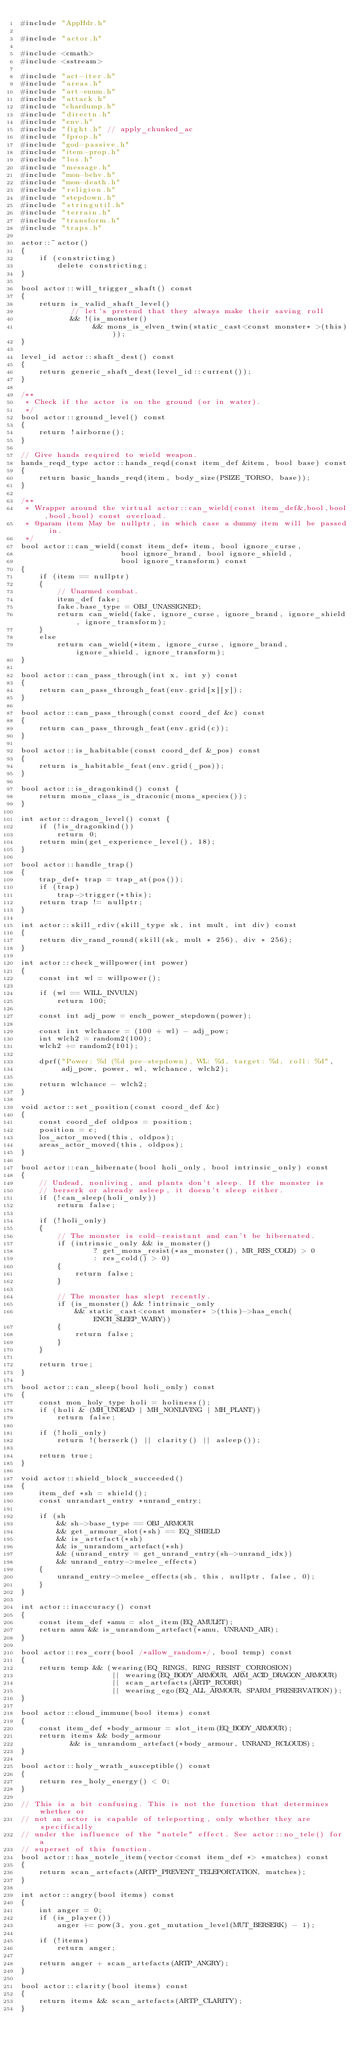<code> <loc_0><loc_0><loc_500><loc_500><_C++_>#include "AppHdr.h"

#include "actor.h"

#include <cmath>
#include <sstream>

#include "act-iter.h"
#include "areas.h"
#include "art-enum.h"
#include "attack.h"
#include "chardump.h"
#include "directn.h"
#include "env.h"
#include "fight.h" // apply_chunked_ac
#include "fprop.h"
#include "god-passive.h"
#include "item-prop.h"
#include "los.h"
#include "message.h"
#include "mon-behv.h"
#include "mon-death.h"
#include "religion.h"
#include "stepdown.h"
#include "stringutil.h"
#include "terrain.h"
#include "transform.h"
#include "traps.h"

actor::~actor()
{
    if (constricting)
        delete constricting;
}

bool actor::will_trigger_shaft() const
{
    return is_valid_shaft_level()
           // let's pretend that they always make their saving roll
           && !(is_monster()
                && mons_is_elven_twin(static_cast<const monster* >(this)));
}

level_id actor::shaft_dest() const
{
    return generic_shaft_dest(level_id::current());
}

/**
 * Check if the actor is on the ground (or in water).
 */
bool actor::ground_level() const
{
    return !airborne();
}

// Give hands required to wield weapon.
hands_reqd_type actor::hands_reqd(const item_def &item, bool base) const
{
    return basic_hands_reqd(item, body_size(PSIZE_TORSO, base));
}

/**
 * Wrapper around the virtual actor::can_wield(const item_def&,bool,bool,bool,bool) const overload.
 * @param item May be nullptr, in which case a dummy item will be passed in.
 */
bool actor::can_wield(const item_def* item, bool ignore_curse,
                      bool ignore_brand, bool ignore_shield,
                      bool ignore_transform) const
{
    if (item == nullptr)
    {
        // Unarmed combat.
        item_def fake;
        fake.base_type = OBJ_UNASSIGNED;
        return can_wield(fake, ignore_curse, ignore_brand, ignore_shield, ignore_transform);
    }
    else
        return can_wield(*item, ignore_curse, ignore_brand, ignore_shield, ignore_transform);
}

bool actor::can_pass_through(int x, int y) const
{
    return can_pass_through_feat(env.grid[x][y]);
}

bool actor::can_pass_through(const coord_def &c) const
{
    return can_pass_through_feat(env.grid(c));
}

bool actor::is_habitable(const coord_def &_pos) const
{
    return is_habitable_feat(env.grid(_pos));
}

bool actor::is_dragonkind() const {
    return mons_class_is_draconic(mons_species());
}

int actor::dragon_level() const {
    if (!is_dragonkind())
        return 0;
    return min(get_experience_level(), 18);
}

bool actor::handle_trap()
{
    trap_def* trap = trap_at(pos());
    if (trap)
        trap->trigger(*this);
    return trap != nullptr;
}

int actor::skill_rdiv(skill_type sk, int mult, int div) const
{
    return div_rand_round(skill(sk, mult * 256), div * 256);
}

int actor::check_willpower(int power)
{
    const int wl = willpower();

    if (wl == WILL_INVULN)
        return 100;

    const int adj_pow = ench_power_stepdown(power);

    const int wlchance = (100 + wl) - adj_pow;
    int wlch2 = random2(100);
    wlch2 += random2(101);

    dprf("Power: %d (%d pre-stepdown), WL: %d, target: %d, roll: %d",
         adj_pow, power, wl, wlchance, wlch2);

    return wlchance - wlch2;
}

void actor::set_position(const coord_def &c)
{
    const coord_def oldpos = position;
    position = c;
    los_actor_moved(this, oldpos);
    areas_actor_moved(this, oldpos);
}

bool actor::can_hibernate(bool holi_only, bool intrinsic_only) const
{
    // Undead, nonliving, and plants don't sleep. If the monster is
    // berserk or already asleep, it doesn't sleep either.
    if (!can_sleep(holi_only))
        return false;

    if (!holi_only)
    {
        // The monster is cold-resistant and can't be hibernated.
        if (intrinsic_only && is_monster()
                ? get_mons_resist(*as_monster(), MR_RES_COLD) > 0
                : res_cold() > 0)
        {
            return false;
        }

        // The monster has slept recently.
        if (is_monster() && !intrinsic_only
            && static_cast<const monster* >(this)->has_ench(ENCH_SLEEP_WARY))
        {
            return false;
        }
    }

    return true;
}

bool actor::can_sleep(bool holi_only) const
{
    const mon_holy_type holi = holiness();
    if (holi & (MH_UNDEAD | MH_NONLIVING | MH_PLANT))
        return false;

    if (!holi_only)
        return !(berserk() || clarity() || asleep());

    return true;
}

void actor::shield_block_succeeded()
{
    item_def *sh = shield();
    const unrandart_entry *unrand_entry;

    if (sh
        && sh->base_type == OBJ_ARMOUR
        && get_armour_slot(*sh) == EQ_SHIELD
        && is_artefact(*sh)
        && is_unrandom_artefact(*sh)
        && (unrand_entry = get_unrand_entry(sh->unrand_idx))
        && unrand_entry->melee_effects)
    {
        unrand_entry->melee_effects(sh, this, nullptr, false, 0);
    }
}

int actor::inaccuracy() const
{
    const item_def *amu = slot_item(EQ_AMULET);
    return amu && is_unrandom_artefact(*amu, UNRAND_AIR);
}

bool actor::res_corr(bool /*allow_random*/, bool temp) const
{
    return temp && (wearing(EQ_RINGS, RING_RESIST_CORROSION)
                    || wearing(EQ_BODY_ARMOUR, ARM_ACID_DRAGON_ARMOUR)
                    || scan_artefacts(ARTP_RCORR)
                    || wearing_ego(EQ_ALL_ARMOUR, SPARM_PRESERVATION));
}

bool actor::cloud_immune(bool items) const
{
    const item_def *body_armour = slot_item(EQ_BODY_ARMOUR);
    return items && body_armour
           && is_unrandom_artefact(*body_armour, UNRAND_RCLOUDS);
}

bool actor::holy_wrath_susceptible() const
{
    return res_holy_energy() < 0;
}

// This is a bit confusing. This is not the function that determines whether or
// not an actor is capable of teleporting, only whether they are specifically
// under the influence of the "notele" effect. See actor::no_tele() for a
// superset of this function.
bool actor::has_notele_item(vector<const item_def *> *matches) const
{
    return scan_artefacts(ARTP_PREVENT_TELEPORTATION, matches);
}

int actor::angry(bool items) const
{
    int anger = 0;
    if (is_player())
        anger += pow(3, you.get_mutation_level(MUT_BERSERK) - 1);

    if (!items)
        return anger;

    return anger + scan_artefacts(ARTP_ANGRY);
}

bool actor::clarity(bool items) const
{
    return items && scan_artefacts(ARTP_CLARITY);
}
</code> 